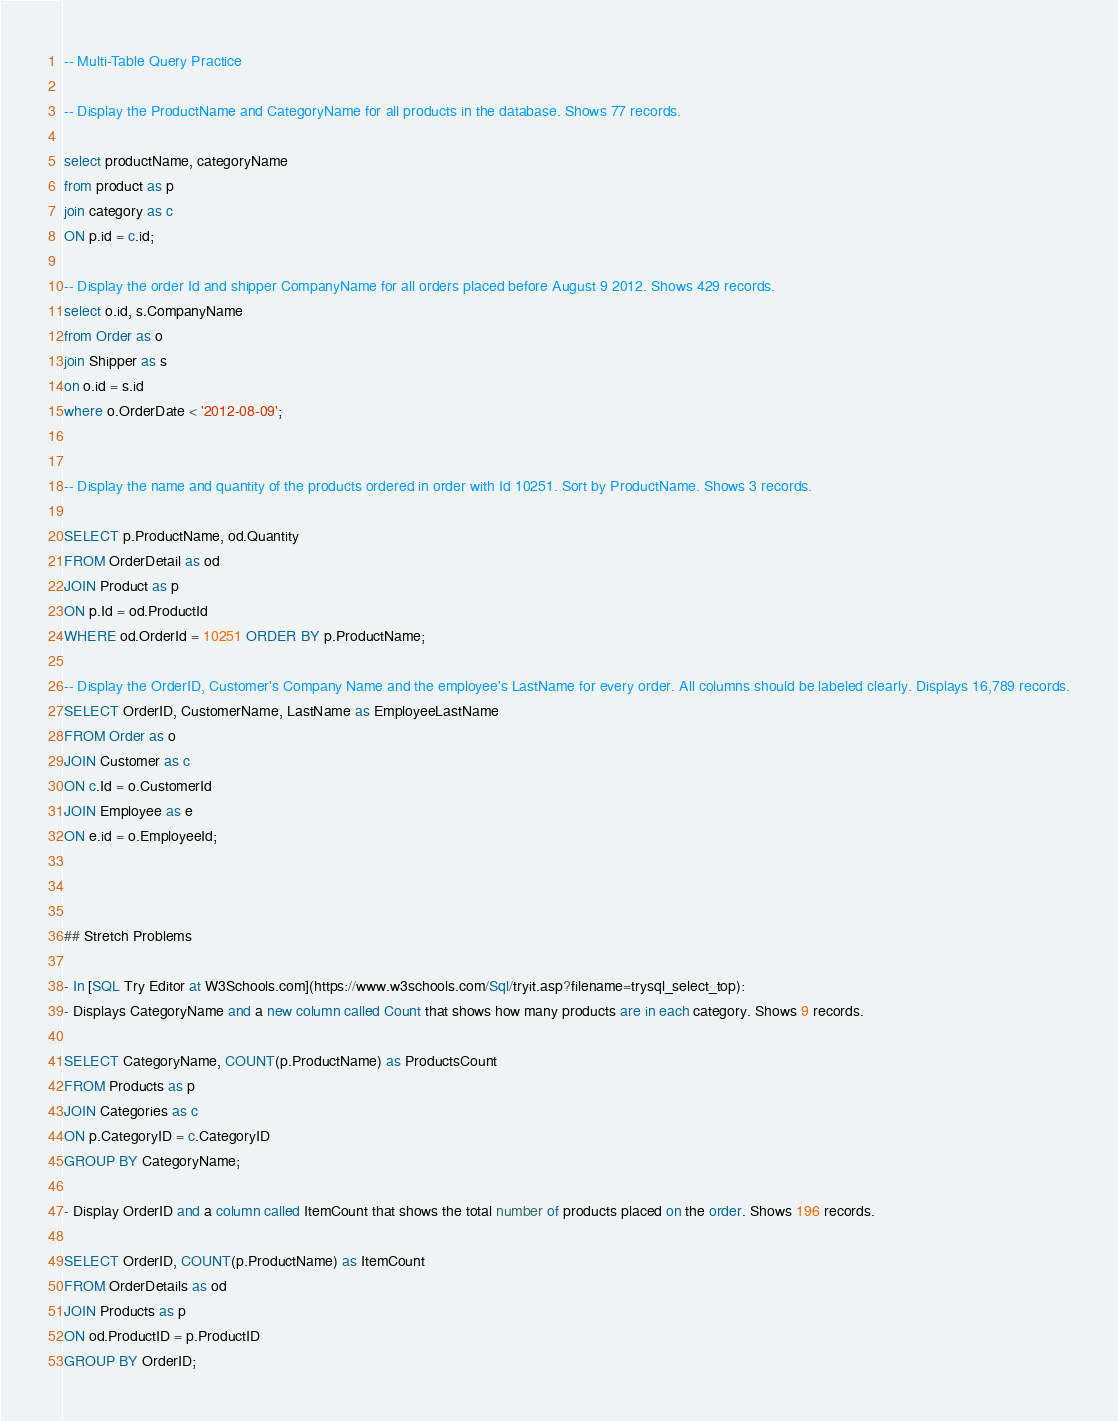Convert code to text. <code><loc_0><loc_0><loc_500><loc_500><_SQL_>-- Multi-Table Query Practice

-- Display the ProductName and CategoryName for all products in the database. Shows 77 records.

select productName, categoryName 
from product as p
join category as c 
ON p.id = c.id; 

-- Display the order Id and shipper CompanyName for all orders placed before August 9 2012. Shows 429 records.
select o.id, s.CompanyName 
from Order as o 
join Shipper as s 
on o.id = s.id 
where o.OrderDate < '2012-08-09';


-- Display the name and quantity of the products ordered in order with Id 10251. Sort by ProductName. Shows 3 records.

SELECT p.ProductName, od.Quantity 
FROM OrderDetail as od 
JOIN Product as p 
ON p.Id = od.ProductId 
WHERE od.OrderId = 10251 ORDER BY p.ProductName;

-- Display the OrderID, Customer's Company Name and the employee's LastName for every order. All columns should be labeled clearly. Displays 16,789 records.
SELECT OrderID, CustomerName, LastName as EmployeeLastName 
FROM Order as o 
JOIN Customer as c 
ON c.Id = o.CustomerId 
JOIN Employee as e 
ON e.id = o.EmployeeId;



## Stretch Problems

- In [SQL Try Editor at W3Schools.com](https://www.w3schools.com/Sql/tryit.asp?filename=trysql_select_top):
- Displays CategoryName and a new column called Count that shows how many products are in each category. Shows 9 records.

SELECT CategoryName, COUNT(p.ProductName) as ProductsCount 
FROM Products as p 
JOIN Categories as c 
ON p.CategoryID = c.CategoryID 
GROUP BY CategoryName;

- Display OrderID and a column called ItemCount that shows the total number of products placed on the order. Shows 196 records.

SELECT OrderID, COUNT(p.ProductName) as ItemCount 
FROM OrderDetails as od 
JOIN Products as p 
ON od.ProductID = p.ProductID 
GROUP BY OrderID;</code> 